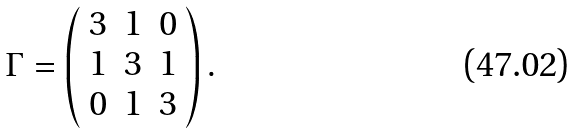Convert formula to latex. <formula><loc_0><loc_0><loc_500><loc_500>\Gamma = \left ( \begin{array} { c c c } 3 & 1 & 0 \\ 1 & 3 & 1 \\ 0 & 1 & 3 \end{array} \right ) .</formula> 